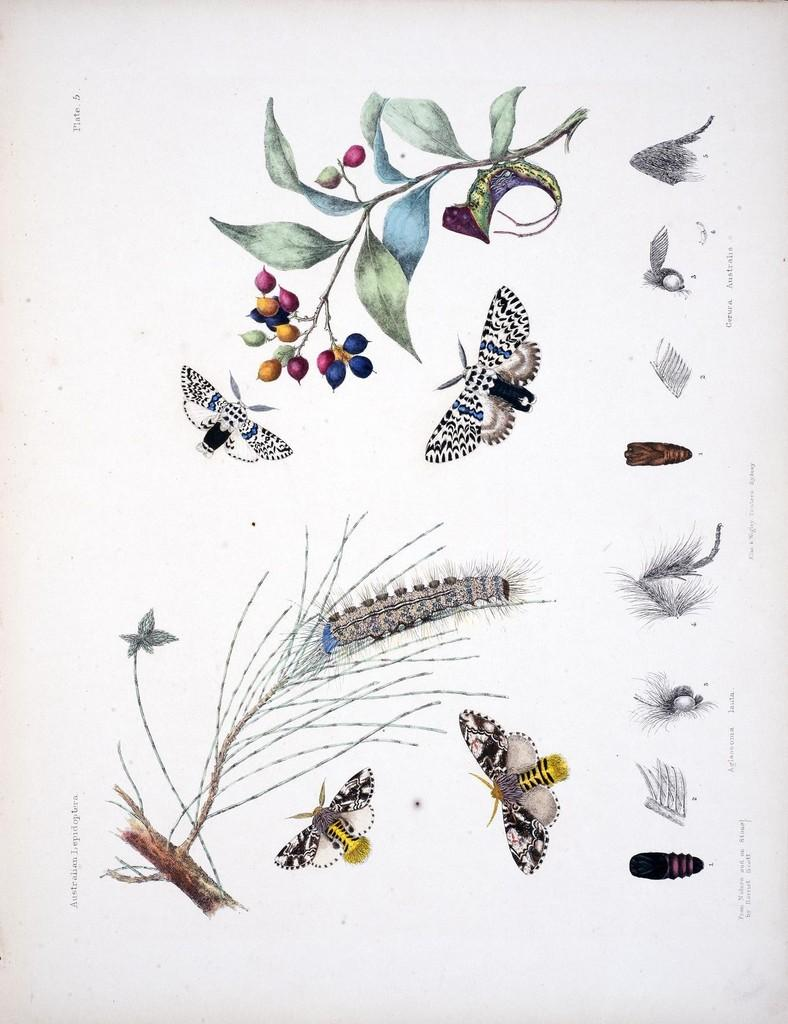What is depicted in the paintings in the image? There are paintings of flies in the image. Can you describe the content of the paintings in more detail? Yes, there are two different branches of plants depicted in the paintings. What type of vein is visible in the paintings? There is no vein present in the paintings; they depict branches of plants. Is there an army visible in the paintings? There is no army present in the paintings; they depict branches of plants and flies. 